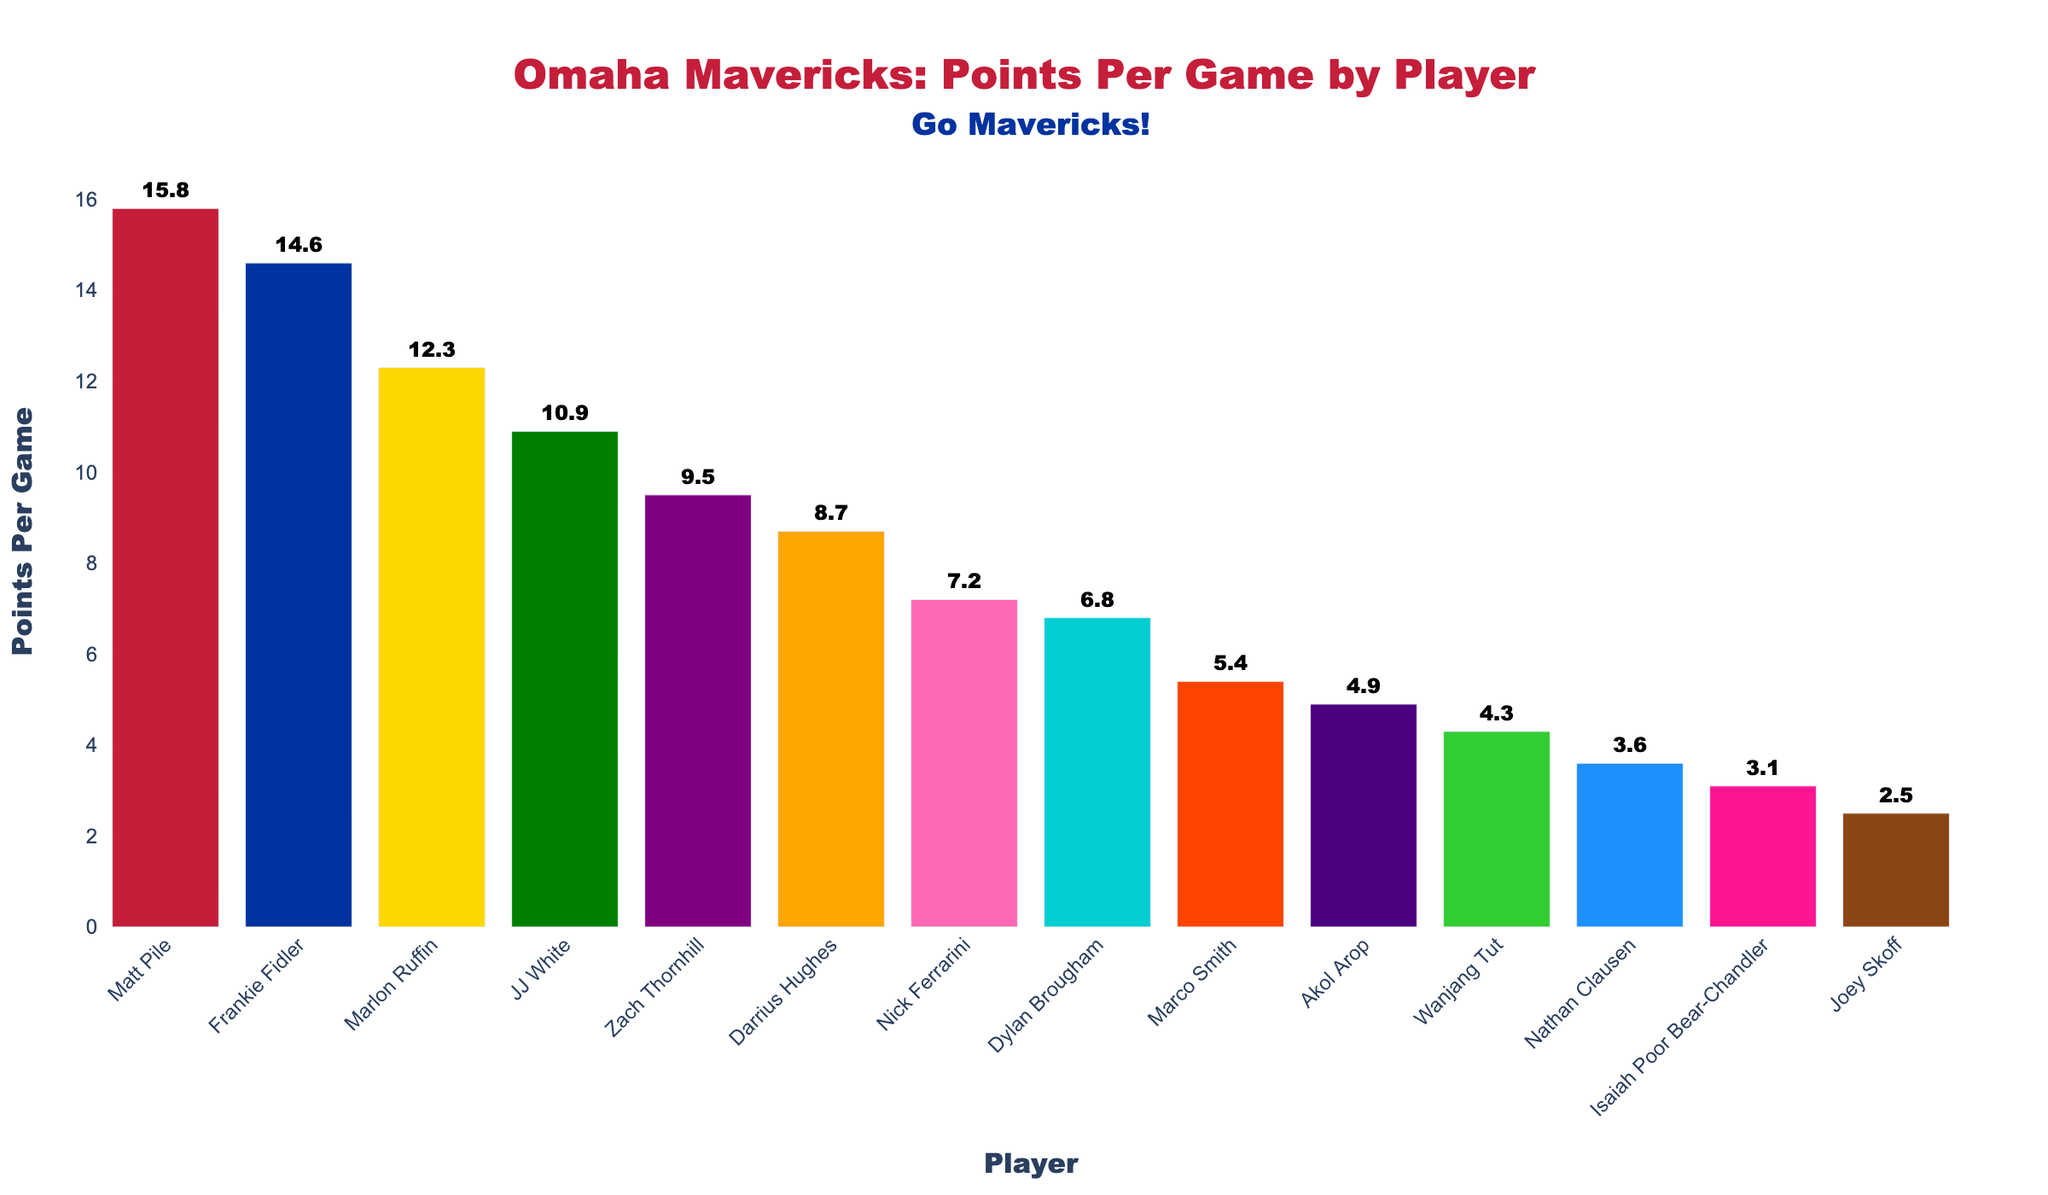Which player has the highest points per game? Look at the height of the bars and the numbers displayed on top; the tallest bar indicates the highest points per game. Matt Pile has the tallest bar with 15.8 points per game.
Answer: Matt Pile Who scored fewer points per game, Zach Thornhill or Nathan Clausen? Compare the heights of the bars labeled with Zach Thornhill and Nathan Clausen. Zach Thornhill's bar reaches 9.5 points per game, while Nathan Clausen's bar is at 3.6 points per game, which is lower.
Answer: Nathan Clausen What is the combined points per game of the two highest-scoring players? The two highest points per game values are 15.8 (Matt Pile) and 14.6 (Frankie Fidler). Add these values together: 15.8 + 14.6 = 30.4.
Answer: 30.4 Which player scores more points per game than JJ White but less than Marlon Ruffin? To find a player with points per game between JJ White (10.9) and Marlon Ruffin (12.3), check each player's number falling in this range. There aren't any players whose scoring fits between these two.
Answer: None What is the average points per game for the top 5 scorers? Identify the top 5 scores: 15.8, 14.6, 12.3, 10.9, and 9.5. Sum these up: 15.8 + 14.6 + 12.3 + 10.9 + 9.5 = 63.1, then divide by 5 for the average: 63.1 / 5 = 12.62.
Answer: 12.62 Which color represents the bar for Marlon Ruffin? Find Marlon Ruffin’s bar (12.3 PPG) and note its color, which is the third bar colored gold.
Answer: Gold How many players have a points per game lower than 7? Count the bars with points per game values below 7. The players are Nick Ferrarini, Dylan Brougham, Marco Smith, Akol Arop, Wanjang Tut, Nathan Clausen, Isaiah Poor Bear-Chandler, and Joey Skoff, making it eight players.
Answer: 8 Calculate the difference in points per game between Darrius Hughes and Isaiah Poor Bear-Chandler. Darrius Hughes scores 8.7 points per game, and Isaiah Poor Bear-Chandler scores 3.1 points per game. Subtract these values: 8.7 - 3.1 = 5.6.
Answer: 5.6 Which players have a points per game difference of at most 1? Check for players with PPG values within 1 of each other:
 - Frankie Fidler (14.6) and Marlon Ruffin (12.3) don't qualify.
 - Marlon Ruffin (12.3) and JJ White (10.9) don't qualify.
 - JJ White (10.9) and Zach Thornhill (9.5) don't qualify.
 - Zach Thornhill (9.5) and Darrius Hughes (8.7) qualify since 9.5 - 8.7 = 0.8.
 - Darrius Hughes (8.7) and Nick Ferrarini (7.2) don't qualify.
Thus, Zach Thornhill and Darrius Hughes.
Answer: Zach Thornhill and Darrius Hughes How many players have a points per game greater than Frankie Fidler? Frankie Fidler scores 14.6 points per game. Only Matt Pile, with 15.8 points per game, has a higher score. Thus, there is only one player.
Answer: 1 